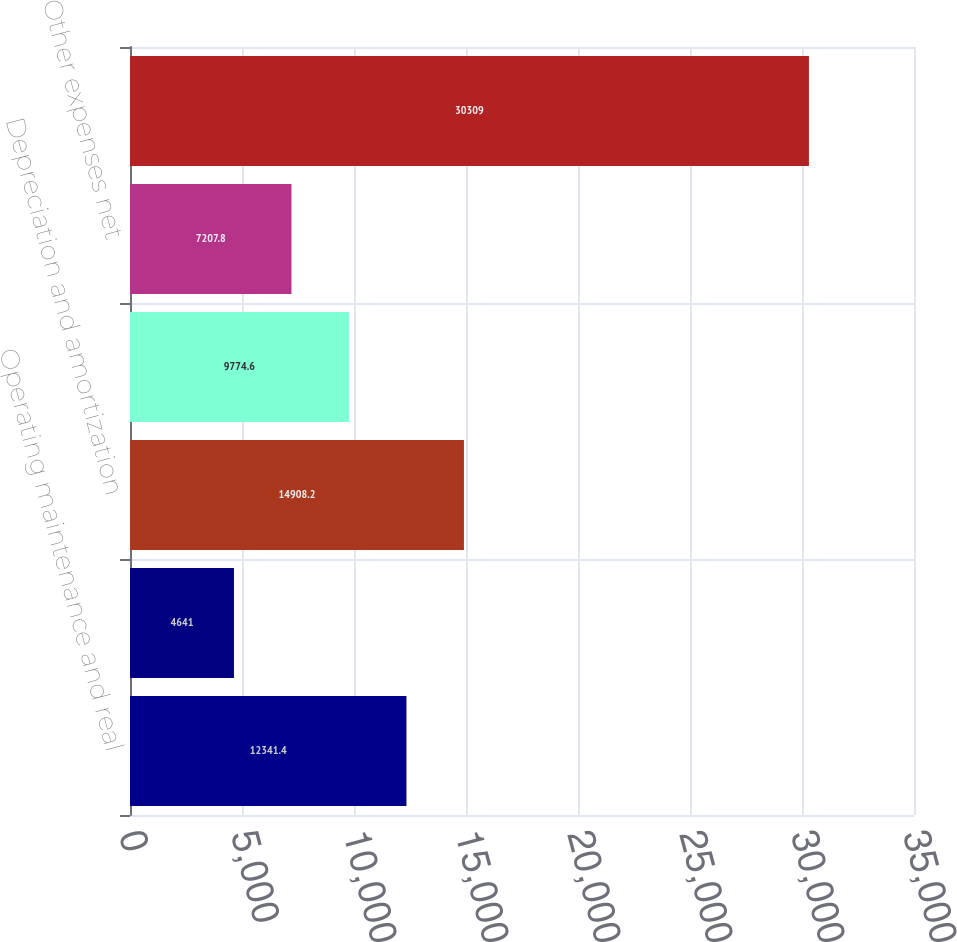Convert chart to OTSL. <chart><loc_0><loc_0><loc_500><loc_500><bar_chart><fcel>Operating maintenance and real<fcel>General and administrative<fcel>Depreciation and amortization<fcel>Provision for doubtful<fcel>Other expenses net<fcel>Total operating expenses<nl><fcel>12341.4<fcel>4641<fcel>14908.2<fcel>9774.6<fcel>7207.8<fcel>30309<nl></chart> 